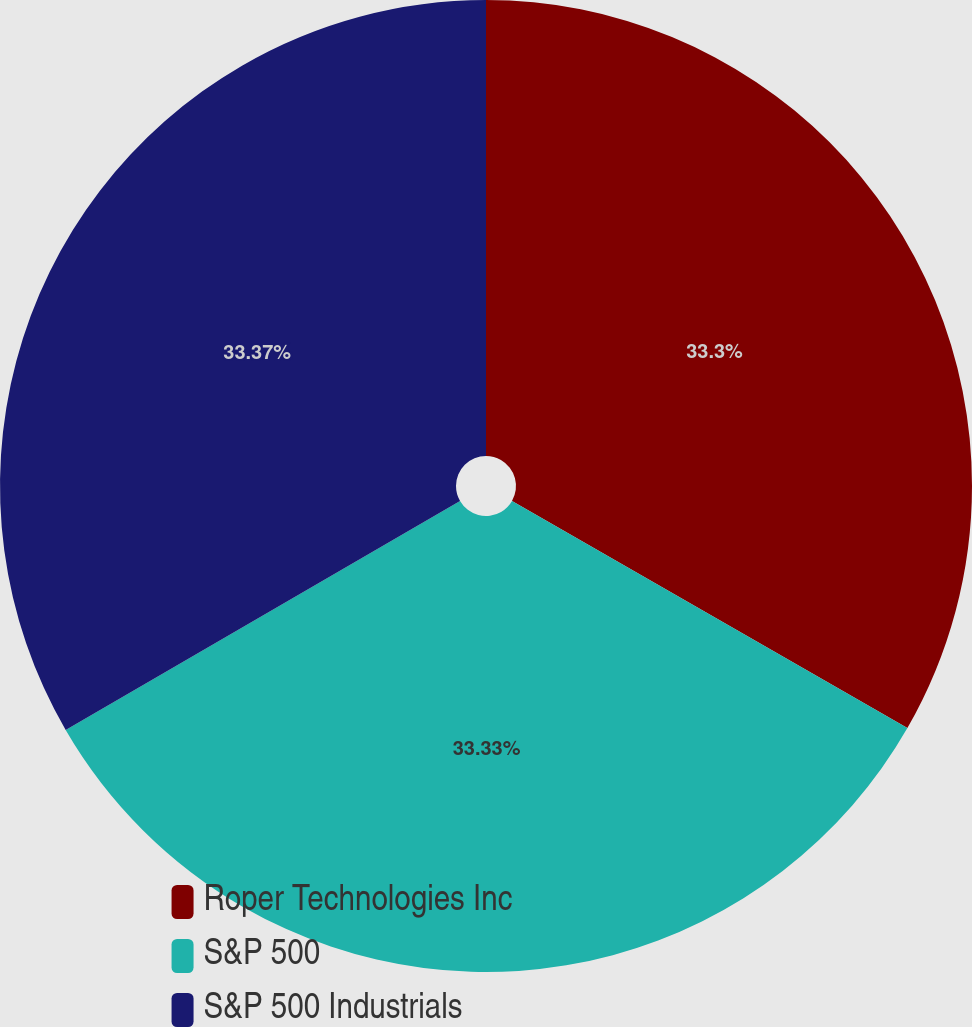Convert chart. <chart><loc_0><loc_0><loc_500><loc_500><pie_chart><fcel>Roper Technologies Inc<fcel>S&P 500<fcel>S&P 500 Industrials<nl><fcel>33.3%<fcel>33.33%<fcel>33.37%<nl></chart> 